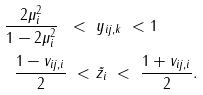Convert formula to latex. <formula><loc_0><loc_0><loc_500><loc_500>\frac { 2 \mu _ { i } ^ { 2 } } { 1 - 2 \mu _ { i } ^ { 2 } } \ < \ & y _ { i j , k } \ < 1 \\ \frac { 1 - v _ { i j , i } } { 2 } \ < \ & \tilde { z _ { i } } \ < \ \frac { 1 + v _ { i j , i } } { 2 } .</formula> 